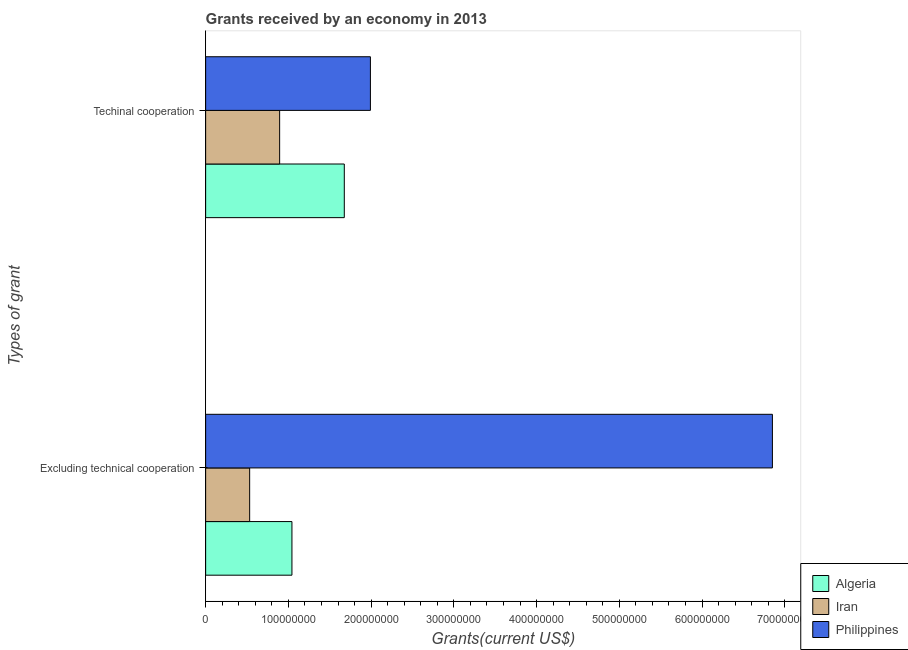Are the number of bars on each tick of the Y-axis equal?
Make the answer very short. Yes. What is the label of the 1st group of bars from the top?
Keep it short and to the point. Techinal cooperation. What is the amount of grants received(including technical cooperation) in Algeria?
Offer a very short reply. 1.68e+08. Across all countries, what is the maximum amount of grants received(including technical cooperation)?
Your response must be concise. 1.99e+08. Across all countries, what is the minimum amount of grants received(excluding technical cooperation)?
Provide a short and direct response. 5.32e+07. In which country was the amount of grants received(excluding technical cooperation) maximum?
Offer a terse response. Philippines. In which country was the amount of grants received(including technical cooperation) minimum?
Give a very brief answer. Iran. What is the total amount of grants received(excluding technical cooperation) in the graph?
Provide a succinct answer. 8.43e+08. What is the difference between the amount of grants received(excluding technical cooperation) in Iran and that in Algeria?
Your answer should be compact. -5.11e+07. What is the difference between the amount of grants received(excluding technical cooperation) in Algeria and the amount of grants received(including technical cooperation) in Philippines?
Your answer should be compact. -9.48e+07. What is the average amount of grants received(including technical cooperation) per country?
Offer a very short reply. 1.52e+08. What is the difference between the amount of grants received(excluding technical cooperation) and amount of grants received(including technical cooperation) in Algeria?
Ensure brevity in your answer.  -6.33e+07. What is the ratio of the amount of grants received(including technical cooperation) in Iran to that in Algeria?
Make the answer very short. 0.53. In how many countries, is the amount of grants received(including technical cooperation) greater than the average amount of grants received(including technical cooperation) taken over all countries?
Your answer should be very brief. 2. What does the 1st bar from the top in Excluding technical cooperation represents?
Offer a terse response. Philippines. What does the 3rd bar from the bottom in Excluding technical cooperation represents?
Your response must be concise. Philippines. How many countries are there in the graph?
Provide a short and direct response. 3. Are the values on the major ticks of X-axis written in scientific E-notation?
Provide a short and direct response. No. Does the graph contain any zero values?
Your answer should be very brief. No. Does the graph contain grids?
Provide a succinct answer. No. What is the title of the graph?
Provide a short and direct response. Grants received by an economy in 2013. Does "French Polynesia" appear as one of the legend labels in the graph?
Make the answer very short. No. What is the label or title of the X-axis?
Your answer should be compact. Grants(current US$). What is the label or title of the Y-axis?
Provide a short and direct response. Types of grant. What is the Grants(current US$) of Algeria in Excluding technical cooperation?
Offer a very short reply. 1.04e+08. What is the Grants(current US$) in Iran in Excluding technical cooperation?
Your response must be concise. 5.32e+07. What is the Grants(current US$) of Philippines in Excluding technical cooperation?
Ensure brevity in your answer.  6.85e+08. What is the Grants(current US$) in Algeria in Techinal cooperation?
Your answer should be very brief. 1.68e+08. What is the Grants(current US$) in Iran in Techinal cooperation?
Offer a terse response. 8.94e+07. What is the Grants(current US$) of Philippines in Techinal cooperation?
Your response must be concise. 1.99e+08. Across all Types of grant, what is the maximum Grants(current US$) in Algeria?
Your response must be concise. 1.68e+08. Across all Types of grant, what is the maximum Grants(current US$) of Iran?
Your answer should be compact. 8.94e+07. Across all Types of grant, what is the maximum Grants(current US$) of Philippines?
Offer a very short reply. 6.85e+08. Across all Types of grant, what is the minimum Grants(current US$) of Algeria?
Offer a very short reply. 1.04e+08. Across all Types of grant, what is the minimum Grants(current US$) in Iran?
Provide a short and direct response. 5.32e+07. Across all Types of grant, what is the minimum Grants(current US$) in Philippines?
Ensure brevity in your answer.  1.99e+08. What is the total Grants(current US$) in Algeria in the graph?
Your response must be concise. 2.72e+08. What is the total Grants(current US$) in Iran in the graph?
Offer a very short reply. 1.43e+08. What is the total Grants(current US$) in Philippines in the graph?
Give a very brief answer. 8.84e+08. What is the difference between the Grants(current US$) in Algeria in Excluding technical cooperation and that in Techinal cooperation?
Make the answer very short. -6.33e+07. What is the difference between the Grants(current US$) in Iran in Excluding technical cooperation and that in Techinal cooperation?
Your answer should be compact. -3.62e+07. What is the difference between the Grants(current US$) of Philippines in Excluding technical cooperation and that in Techinal cooperation?
Provide a succinct answer. 4.86e+08. What is the difference between the Grants(current US$) of Algeria in Excluding technical cooperation and the Grants(current US$) of Iran in Techinal cooperation?
Ensure brevity in your answer.  1.49e+07. What is the difference between the Grants(current US$) of Algeria in Excluding technical cooperation and the Grants(current US$) of Philippines in Techinal cooperation?
Keep it short and to the point. -9.48e+07. What is the difference between the Grants(current US$) in Iran in Excluding technical cooperation and the Grants(current US$) in Philippines in Techinal cooperation?
Provide a succinct answer. -1.46e+08. What is the average Grants(current US$) in Algeria per Types of grant?
Your answer should be compact. 1.36e+08. What is the average Grants(current US$) of Iran per Types of grant?
Keep it short and to the point. 7.13e+07. What is the average Grants(current US$) of Philippines per Types of grant?
Make the answer very short. 4.42e+08. What is the difference between the Grants(current US$) of Algeria and Grants(current US$) of Iran in Excluding technical cooperation?
Keep it short and to the point. 5.11e+07. What is the difference between the Grants(current US$) of Algeria and Grants(current US$) of Philippines in Excluding technical cooperation?
Provide a short and direct response. -5.81e+08. What is the difference between the Grants(current US$) of Iran and Grants(current US$) of Philippines in Excluding technical cooperation?
Your answer should be very brief. -6.32e+08. What is the difference between the Grants(current US$) of Algeria and Grants(current US$) of Iran in Techinal cooperation?
Keep it short and to the point. 7.82e+07. What is the difference between the Grants(current US$) of Algeria and Grants(current US$) of Philippines in Techinal cooperation?
Offer a terse response. -3.16e+07. What is the difference between the Grants(current US$) in Iran and Grants(current US$) in Philippines in Techinal cooperation?
Give a very brief answer. -1.10e+08. What is the ratio of the Grants(current US$) in Algeria in Excluding technical cooperation to that in Techinal cooperation?
Ensure brevity in your answer.  0.62. What is the ratio of the Grants(current US$) in Iran in Excluding technical cooperation to that in Techinal cooperation?
Your answer should be very brief. 0.59. What is the ratio of the Grants(current US$) of Philippines in Excluding technical cooperation to that in Techinal cooperation?
Offer a very short reply. 3.44. What is the difference between the highest and the second highest Grants(current US$) in Algeria?
Offer a terse response. 6.33e+07. What is the difference between the highest and the second highest Grants(current US$) of Iran?
Provide a succinct answer. 3.62e+07. What is the difference between the highest and the second highest Grants(current US$) of Philippines?
Offer a terse response. 4.86e+08. What is the difference between the highest and the lowest Grants(current US$) in Algeria?
Your response must be concise. 6.33e+07. What is the difference between the highest and the lowest Grants(current US$) of Iran?
Your answer should be compact. 3.62e+07. What is the difference between the highest and the lowest Grants(current US$) of Philippines?
Provide a short and direct response. 4.86e+08. 